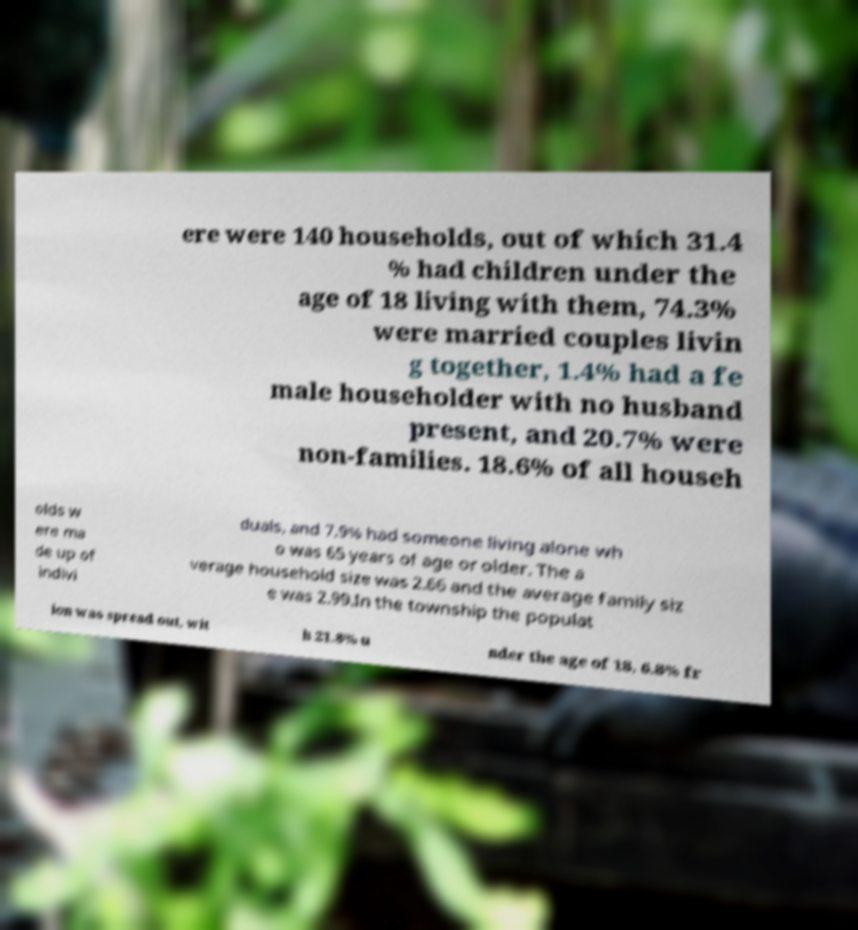What messages or text are displayed in this image? I need them in a readable, typed format. ere were 140 households, out of which 31.4 % had children under the age of 18 living with them, 74.3% were married couples livin g together, 1.4% had a fe male householder with no husband present, and 20.7% were non-families. 18.6% of all househ olds w ere ma de up of indivi duals, and 7.9% had someone living alone wh o was 65 years of age or older. The a verage household size was 2.66 and the average family siz e was 2.99.In the township the populat ion was spread out, wit h 21.8% u nder the age of 18, 6.8% fr 